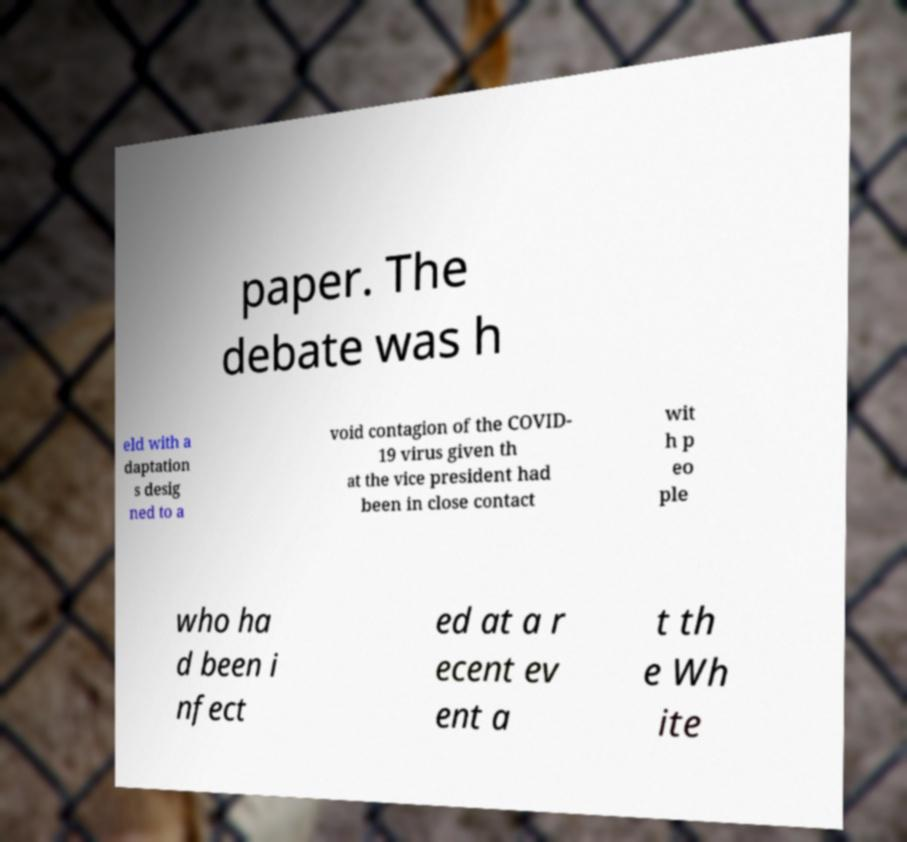Can you accurately transcribe the text from the provided image for me? paper. The debate was h eld with a daptation s desig ned to a void contagion of the COVID- 19 virus given th at the vice president had been in close contact wit h p eo ple who ha d been i nfect ed at a r ecent ev ent a t th e Wh ite 